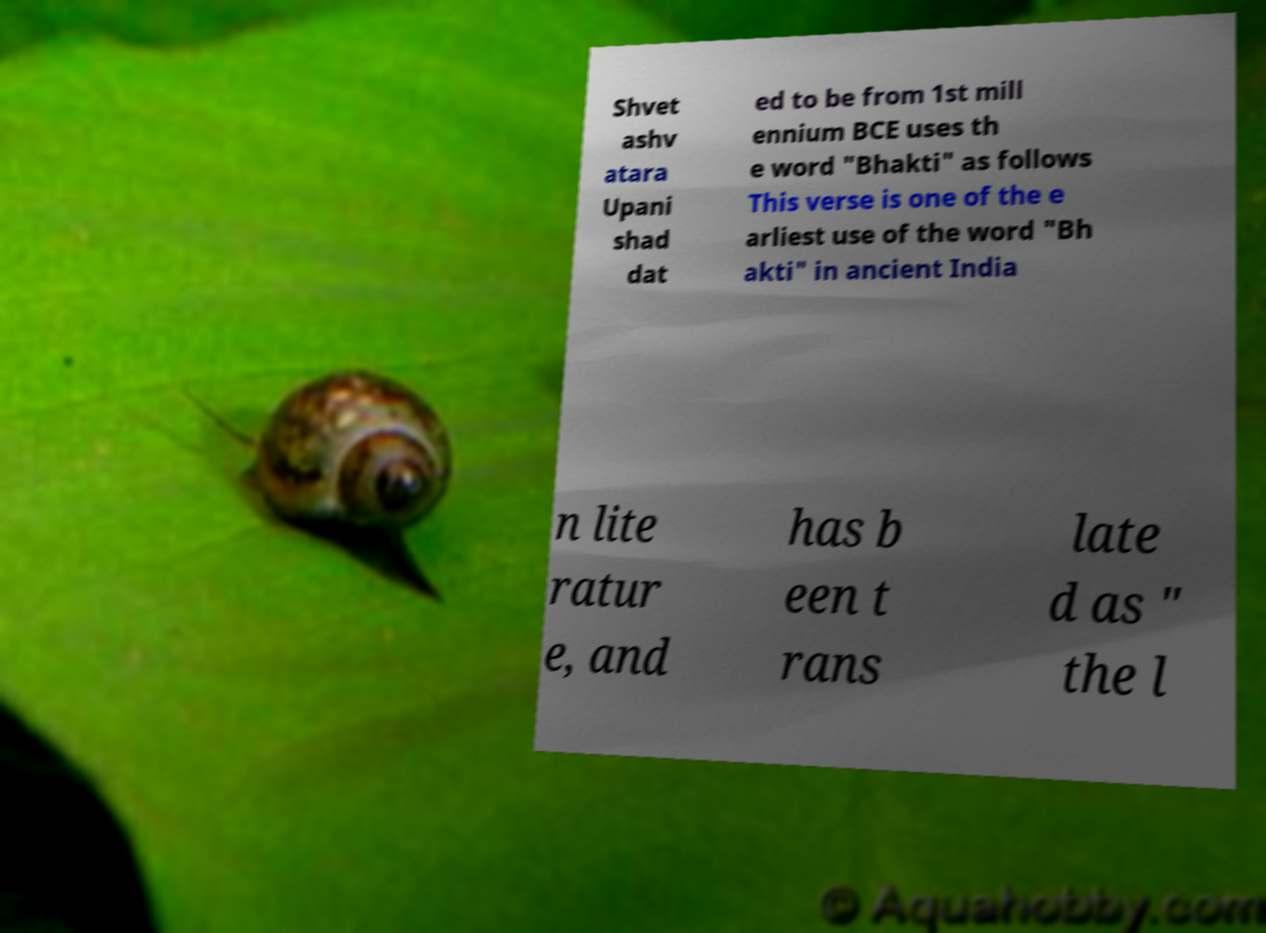Can you read and provide the text displayed in the image?This photo seems to have some interesting text. Can you extract and type it out for me? Shvet ashv atara Upani shad dat ed to be from 1st mill ennium BCE uses th e word "Bhakti" as follows This verse is one of the e arliest use of the word "Bh akti" in ancient India n lite ratur e, and has b een t rans late d as " the l 